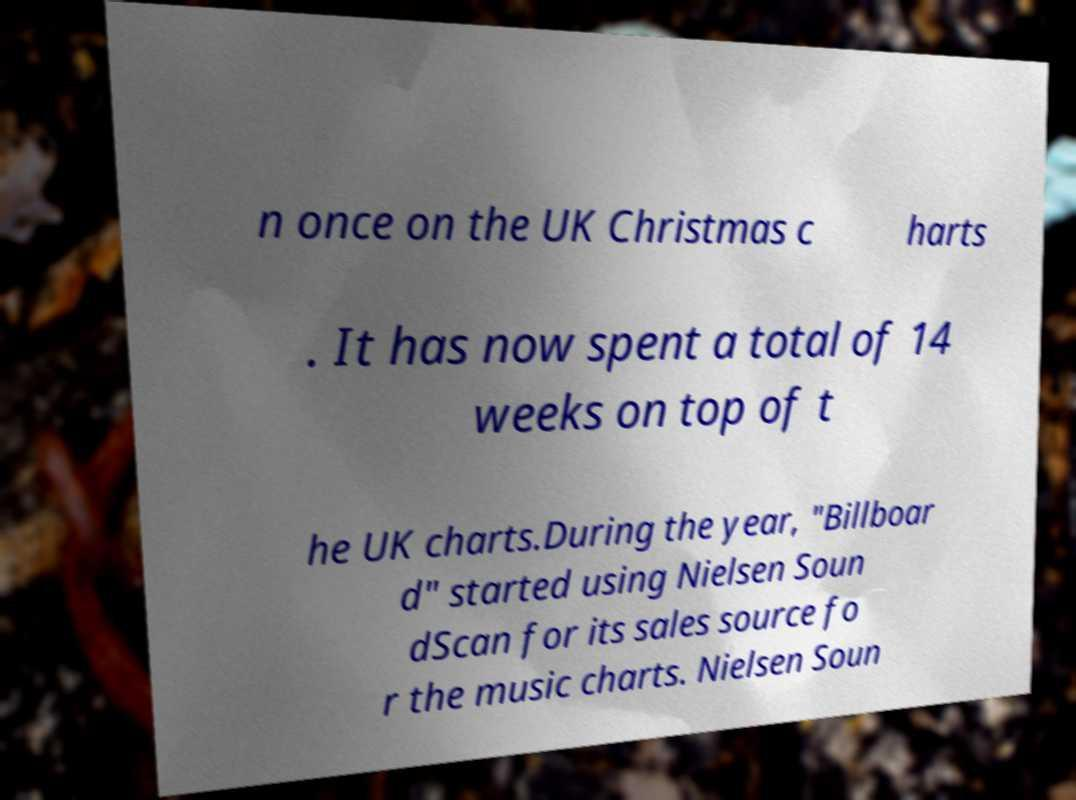Please identify and transcribe the text found in this image. n once on the UK Christmas c harts . It has now spent a total of 14 weeks on top of t he UK charts.During the year, "Billboar d" started using Nielsen Soun dScan for its sales source fo r the music charts. Nielsen Soun 